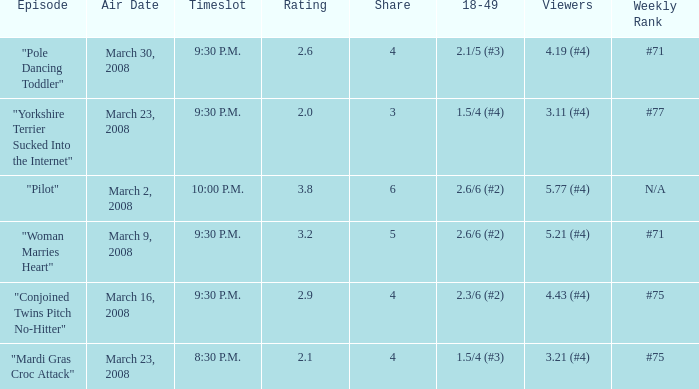What is the total ratings on share less than 4? 1.0. 